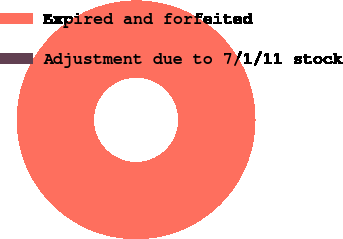Convert chart. <chart><loc_0><loc_0><loc_500><loc_500><pie_chart><fcel>Expired and forfeited<fcel>Adjustment due to 7/1/11 stock<nl><fcel>100.0%<fcel>0.0%<nl></chart> 